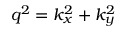<formula> <loc_0><loc_0><loc_500><loc_500>q ^ { 2 } = k _ { x } ^ { 2 } + k _ { y } ^ { 2 }</formula> 